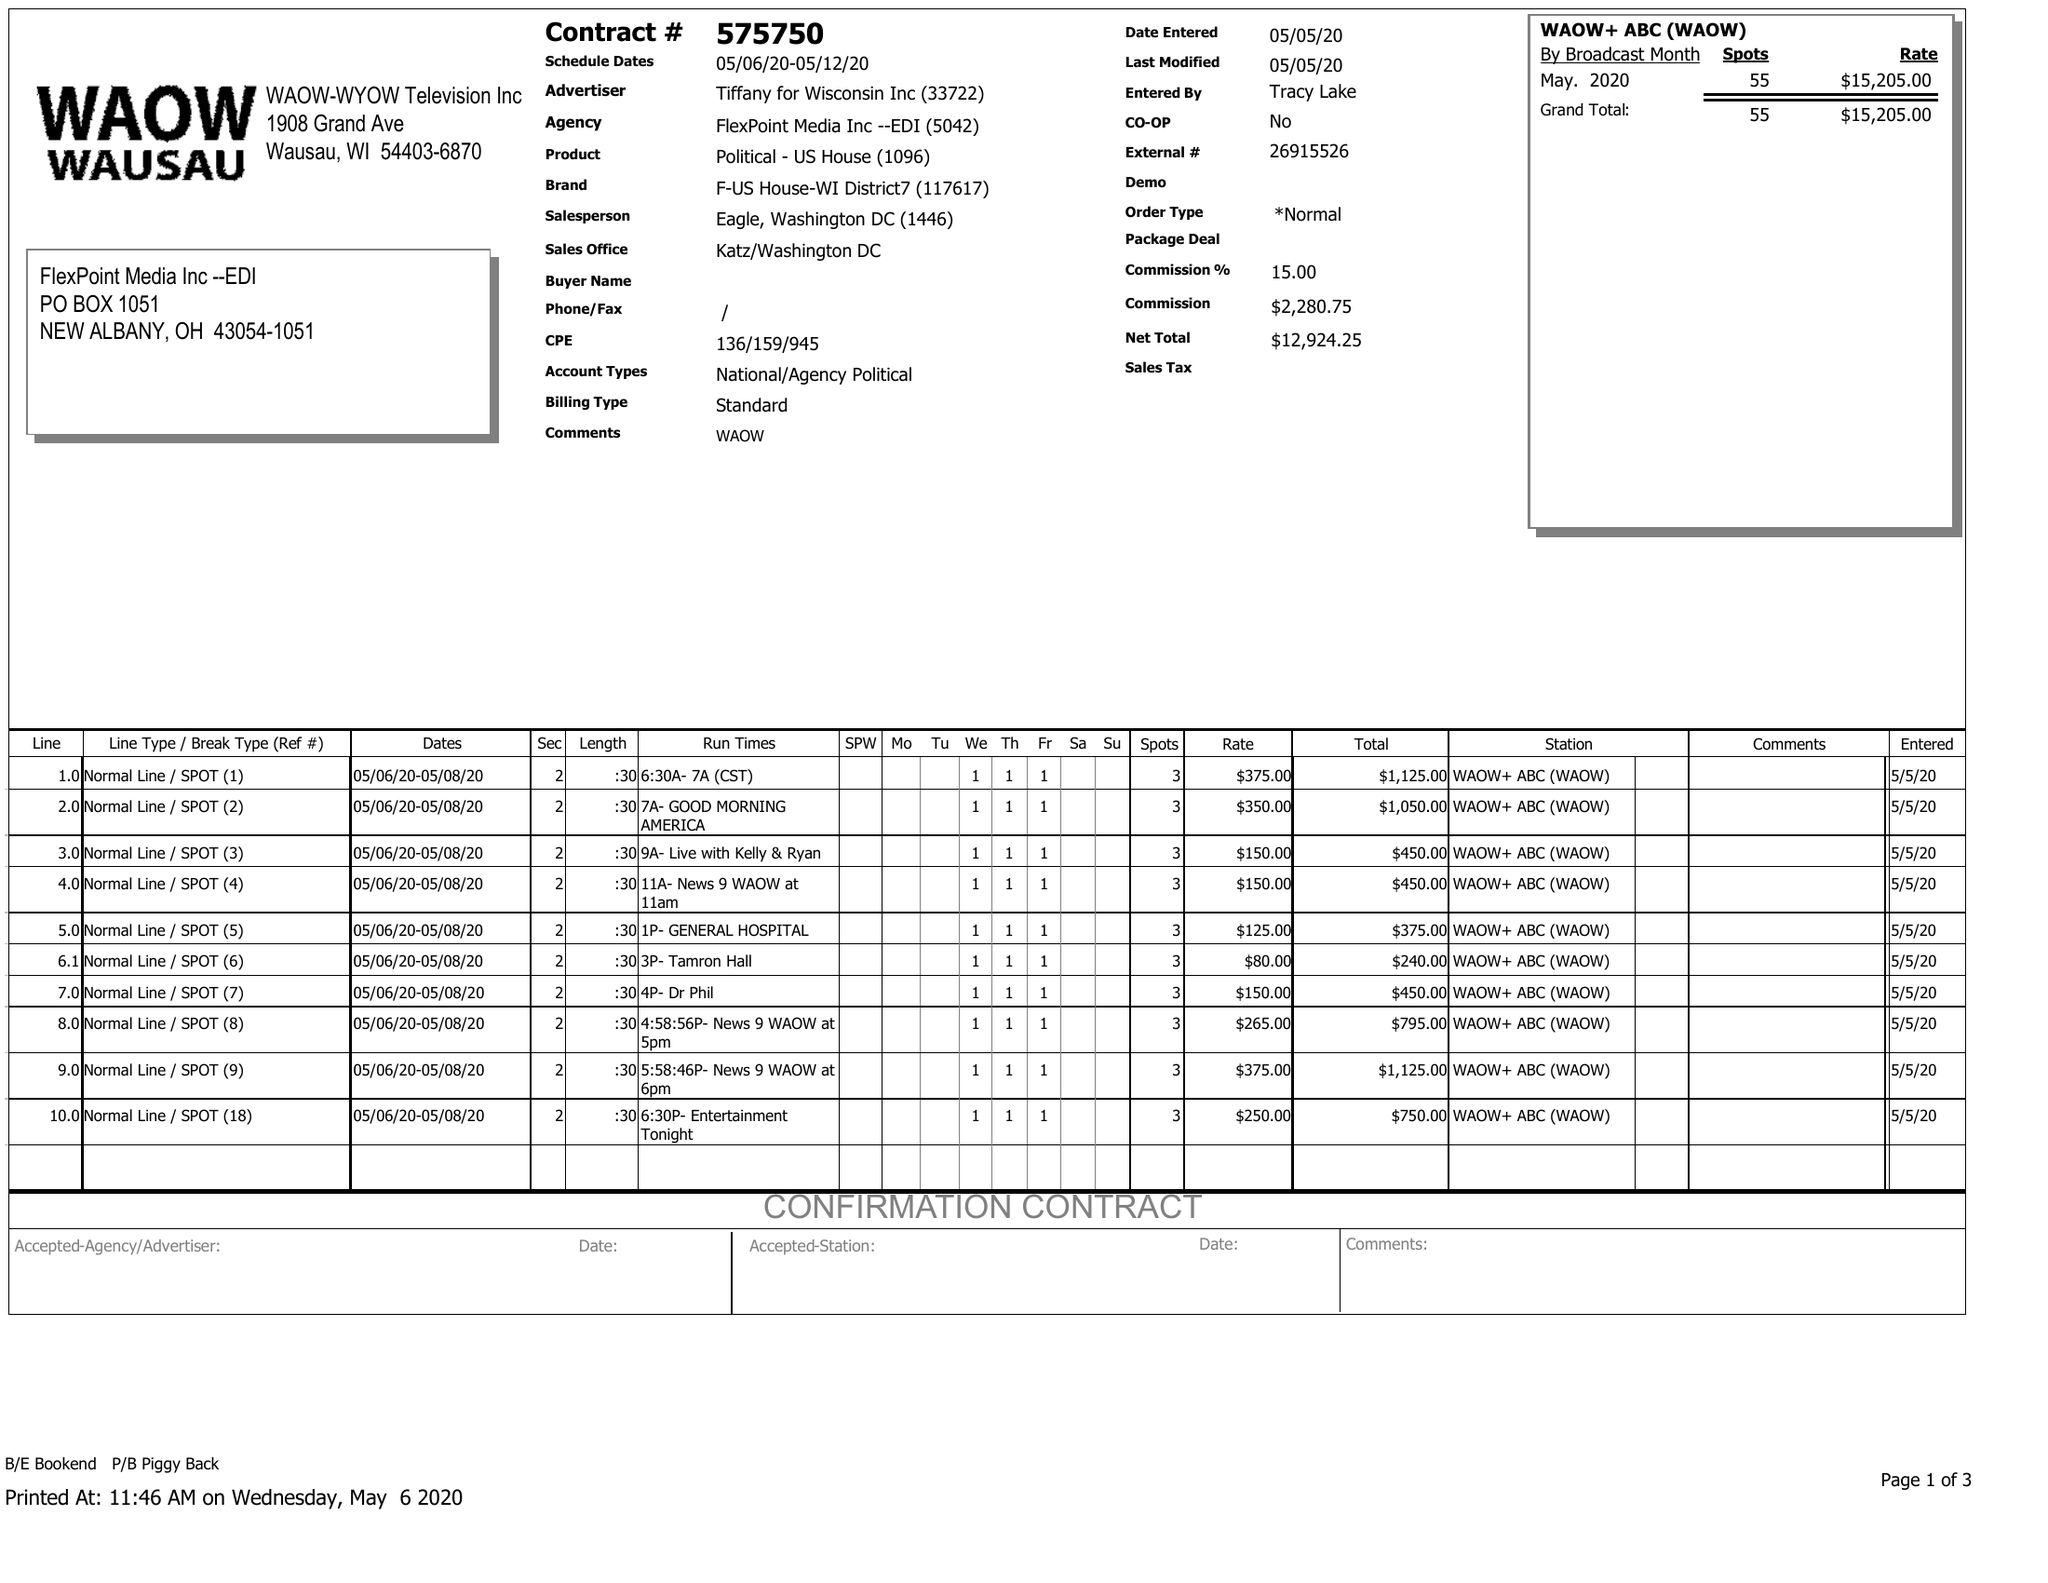What is the value for the flight_from?
Answer the question using a single word or phrase. 05/06/20 